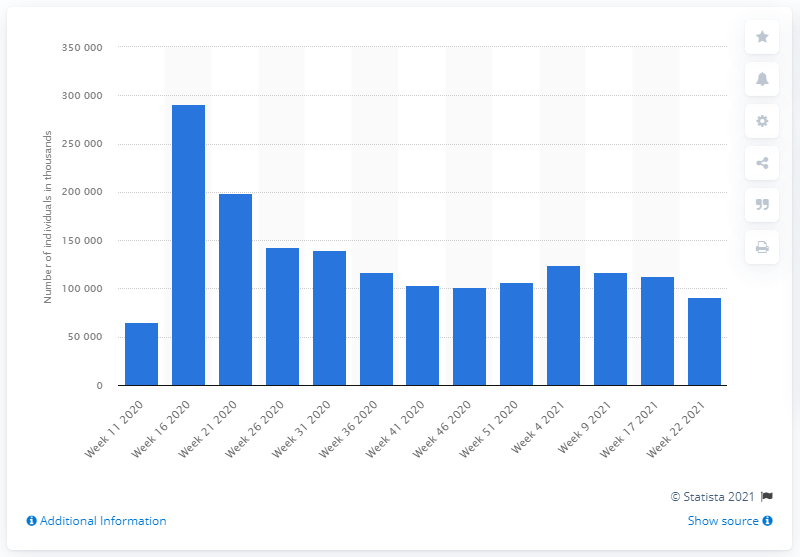Mention a couple of crucial points in this snapshot. In week 11 of 2020, there were 65,340 individuals who were unemployed in Norway. As of Week 22, 2021, the number of unemployed individuals in Norway was 91,412. In week 16 of 2020, there were 291,048 people who were unemployed in Norway. 